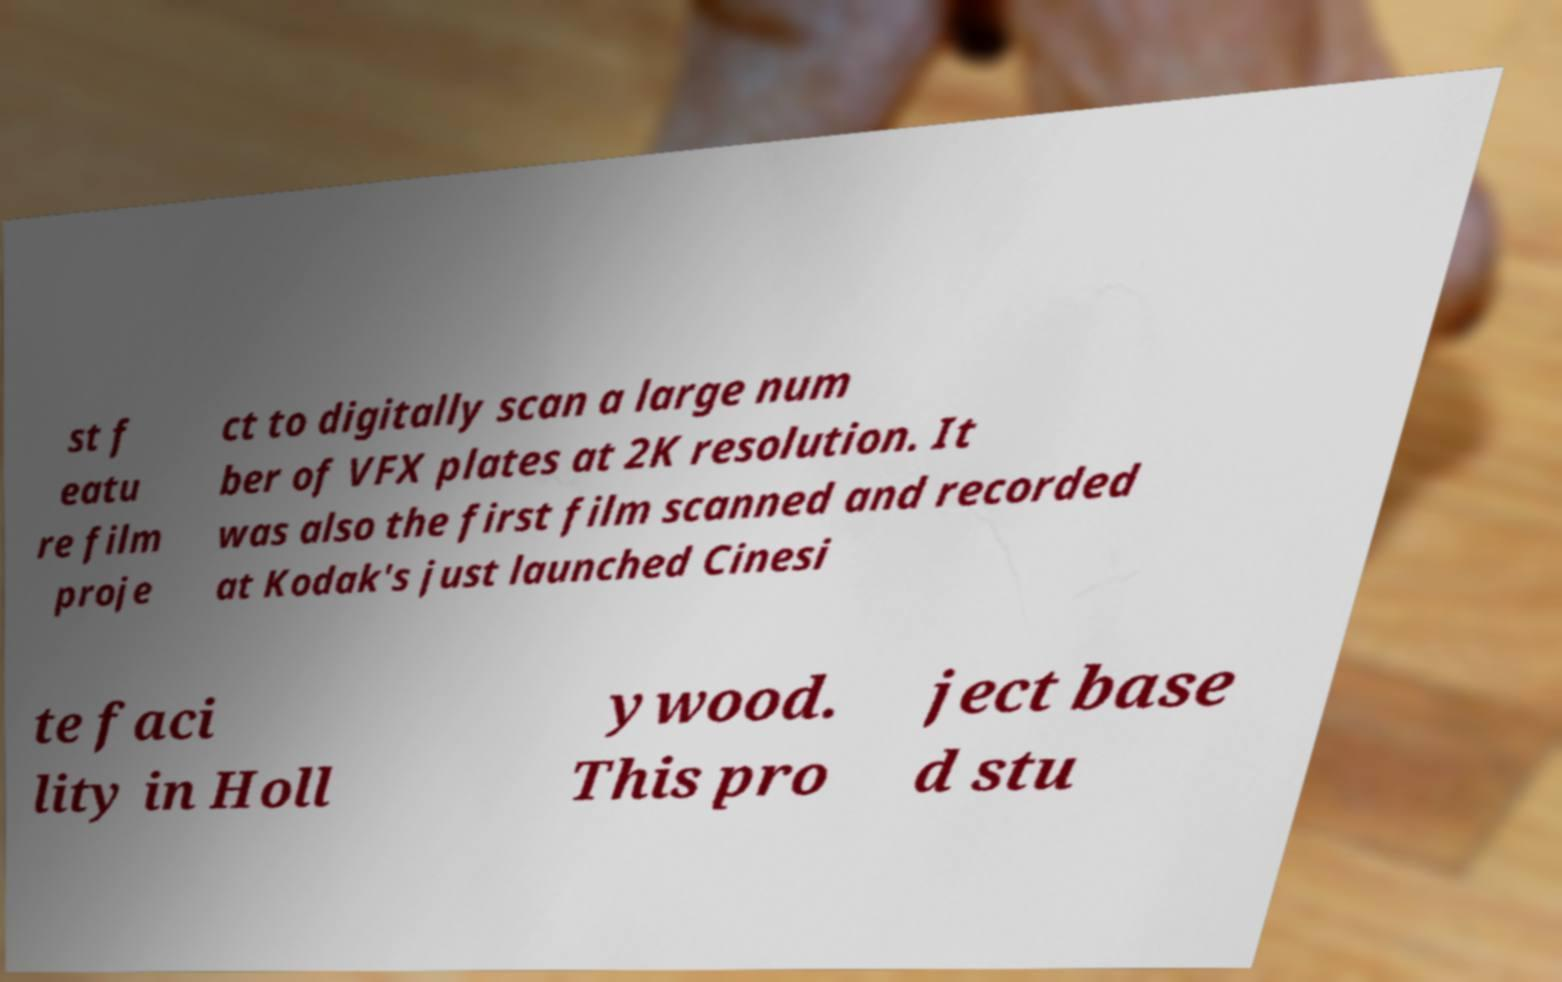Can you read and provide the text displayed in the image?This photo seems to have some interesting text. Can you extract and type it out for me? st f eatu re film proje ct to digitally scan a large num ber of VFX plates at 2K resolution. It was also the first film scanned and recorded at Kodak's just launched Cinesi te faci lity in Holl ywood. This pro ject base d stu 